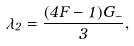<formula> <loc_0><loc_0><loc_500><loc_500>\lambda _ { 2 } = \frac { ( 4 F - 1 ) G _ { - } } { 3 } ,</formula> 